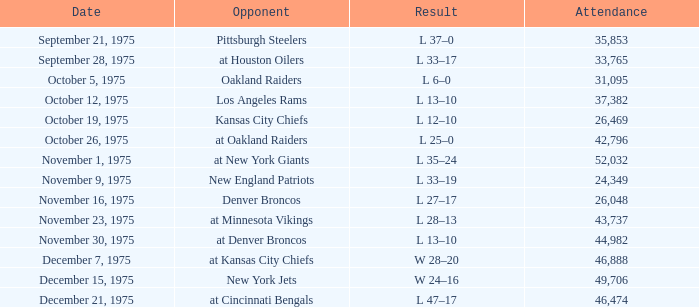What is the lowest Week when the result was l 13–10, November 30, 1975, with more than 44,982 people in attendance? None. 